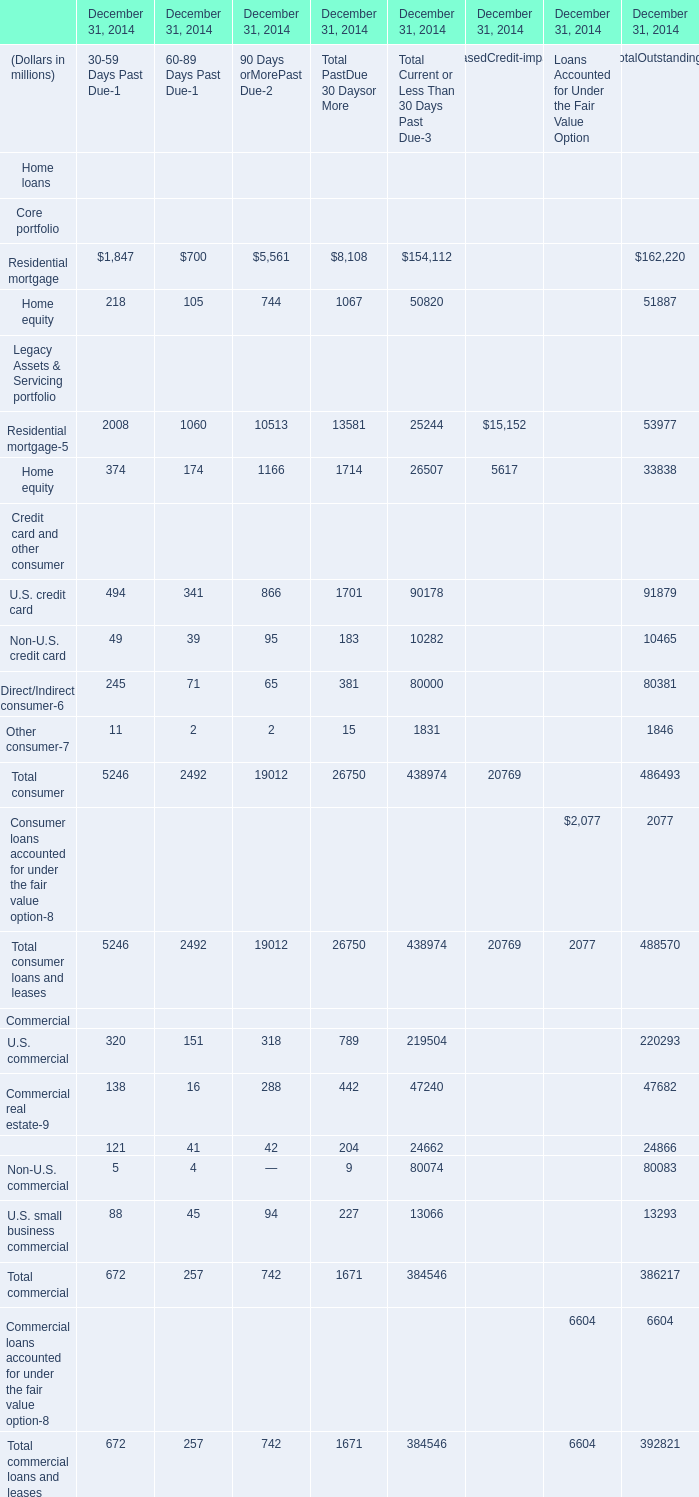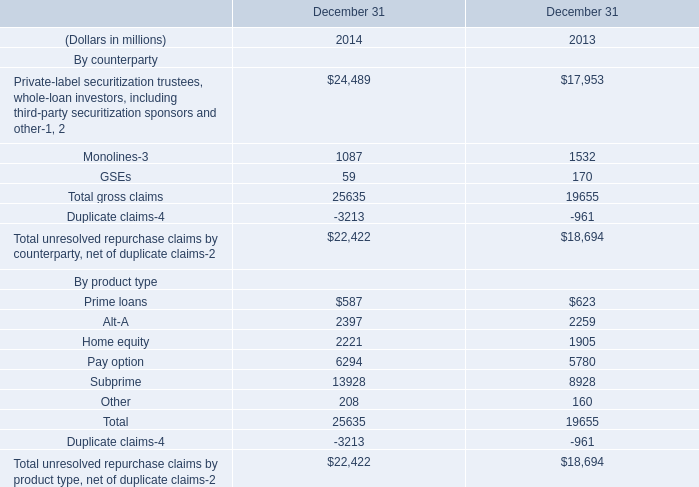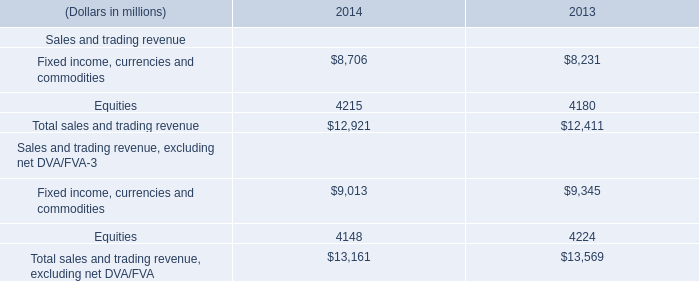What is the total amount of Residential mortgage of December 31, 2014 90 Days orMorePast Due, and Home equity By product type of December 31 2014 ? 
Computations: (5561.0 + 2221.0)
Answer: 7782.0. 